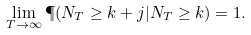<formula> <loc_0><loc_0><loc_500><loc_500>\lim _ { T \to \infty } \P ( N _ { T } \geq k + j | N _ { T } \geq k ) = 1 .</formula> 